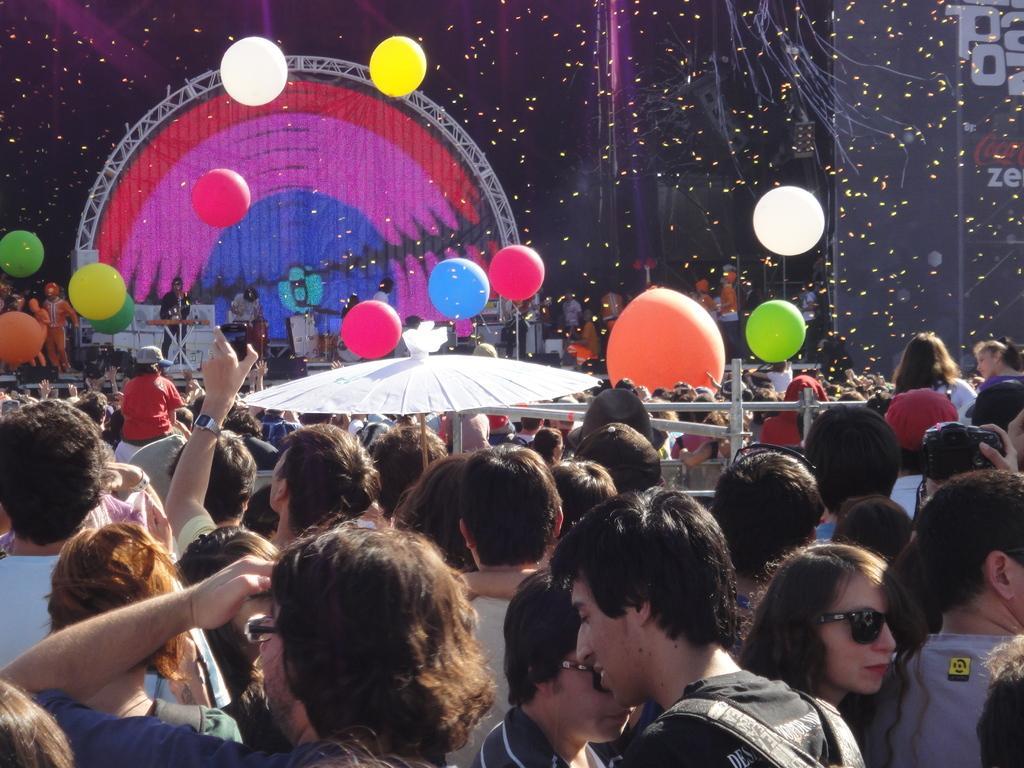Describe this image in one or two sentences. This image consists of many people. It looks like a music concert. There are balloons in the air. In the background, there is a stage on which few people are performing. To the right, there is a screen in black color. 